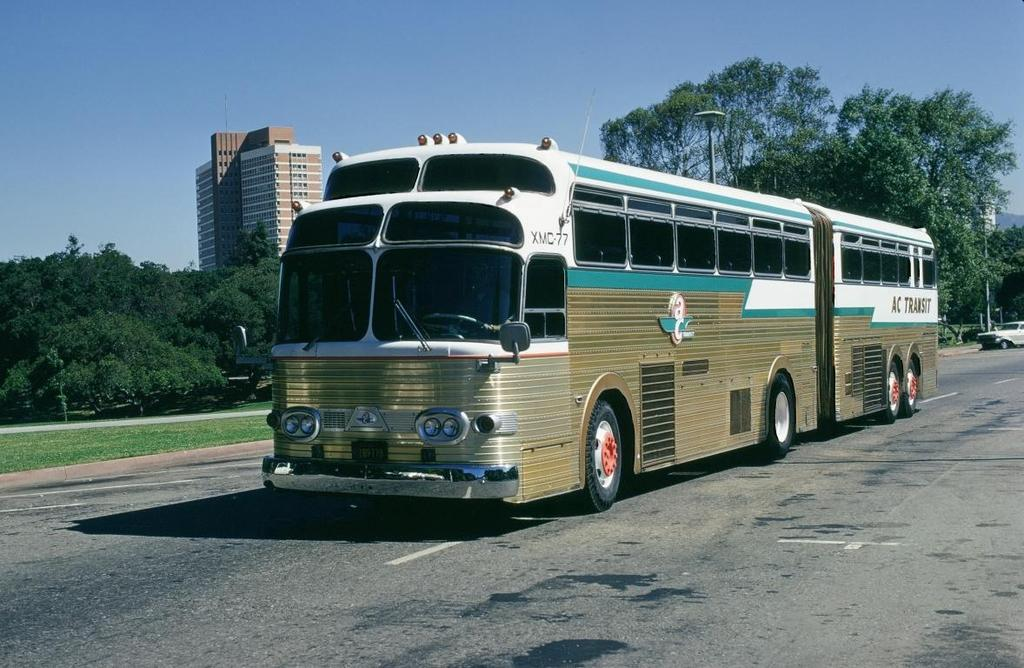What type of vehicle is in the image? There is a gold-colored bus in the image. What is the bus doing in the image? The bus is moving on the road. What can be seen in the background of the image? There are trees, buildings, and the sky visible in the background of the image. Can you see a hen holding a crayon near the gate in the image? No, there is no hen, crayon, or gate present in the image. 